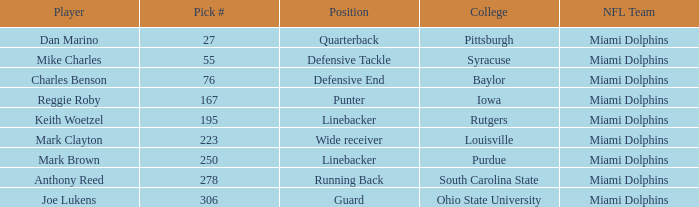Which Position has a Pick # lower than 278 for Player Charles Benson? Defensive End. 